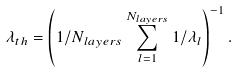Convert formula to latex. <formula><loc_0><loc_0><loc_500><loc_500>\lambda _ { t h } = \left ( 1 / N _ { l a y e r s } \sum _ { l = 1 } ^ { N _ { l a y e r s } } 1 / \lambda _ { l } \right ) ^ { - 1 } .</formula> 